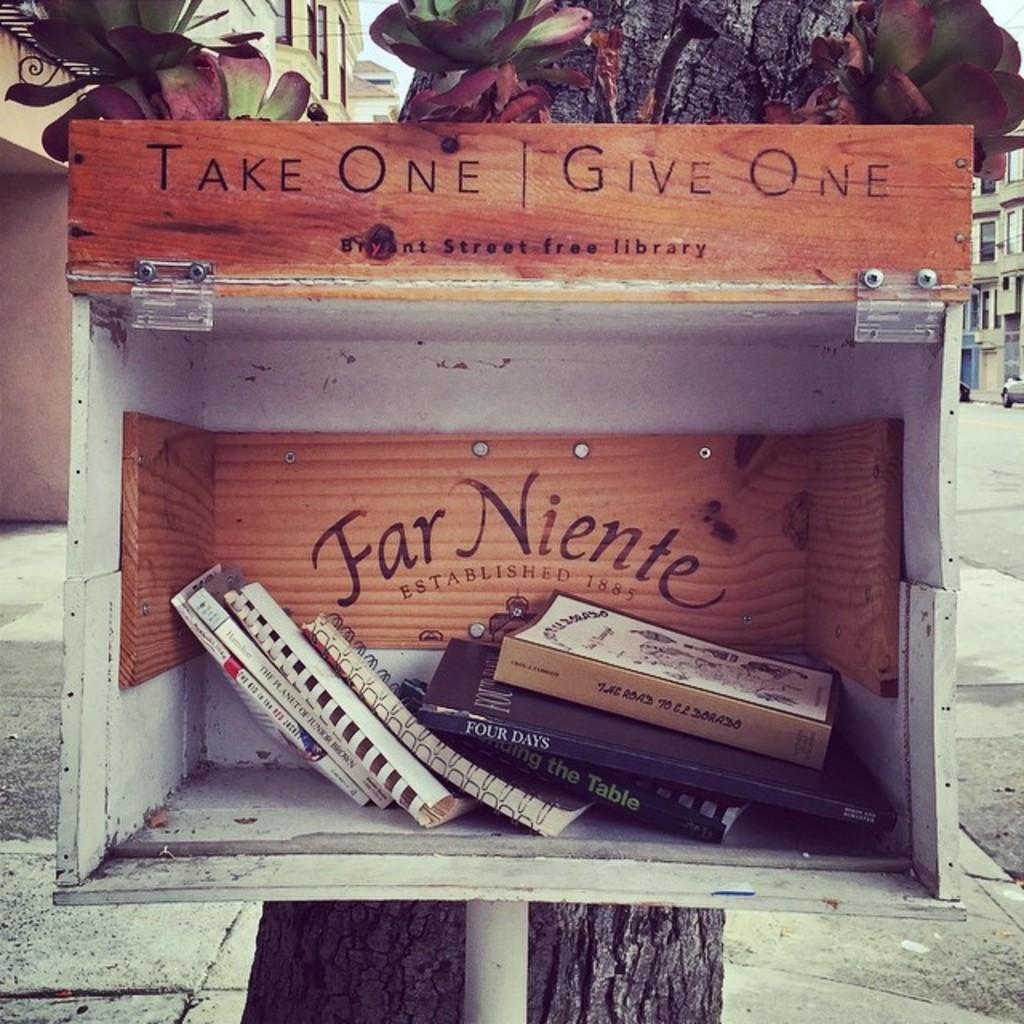<image>
Describe the image concisely. A group of books in a box with a wooden sign that says " Take One Give One" 